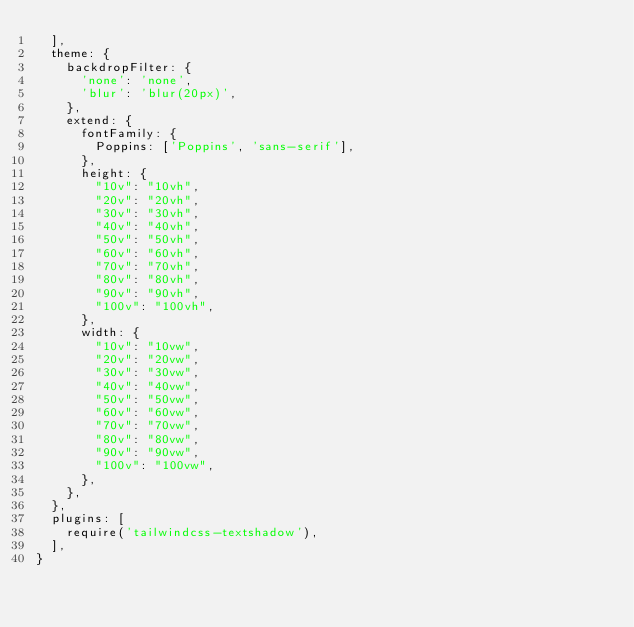<code> <loc_0><loc_0><loc_500><loc_500><_JavaScript_>  ],
  theme: {
    backdropFilter: {
      'none': 'none',
      'blur': 'blur(20px)',
    },
    extend: {
      fontFamily: {
        Poppins: ['Poppins', 'sans-serif'],
      },
      height: {
        "10v": "10vh",
        "20v": "20vh",
        "30v": "30vh",
        "40v": "40vh",
        "50v": "50vh",
        "60v": "60vh",
        "70v": "70vh",
        "80v": "80vh",
        "90v": "90vh",
        "100v": "100vh",
      },
      width: {
        "10v": "10vw",
        "20v": "20vw",
        "30v": "30vw",
        "40v": "40vw",
        "50v": "50vw",
        "60v": "60vw",
        "70v": "70vw",
        "80v": "80vw",
        "90v": "90vw",
        "100v": "100vw",
      },
    },
  },
  plugins: [
    require('tailwindcss-textshadow'),
  ],
}
</code> 